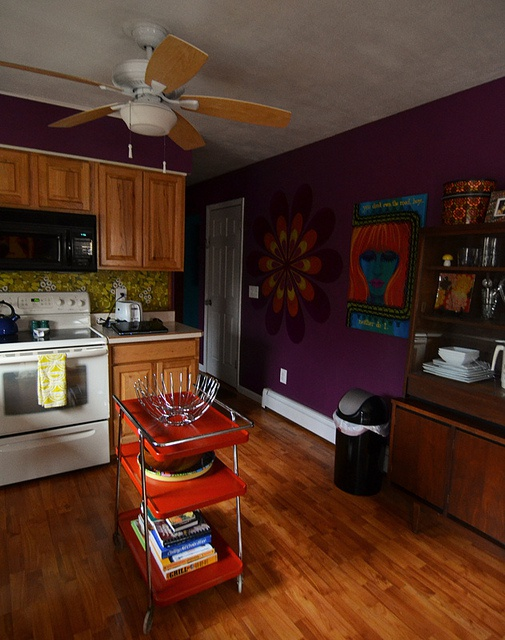Describe the objects in this image and their specific colors. I can see oven in gray, darkgray, lightgray, and black tones, microwave in gray, black, and darkgray tones, bowl in gray, maroon, brown, and black tones, vase in gray, black, maroon, and brown tones, and book in gray, red, lightgray, darkgray, and orange tones in this image. 